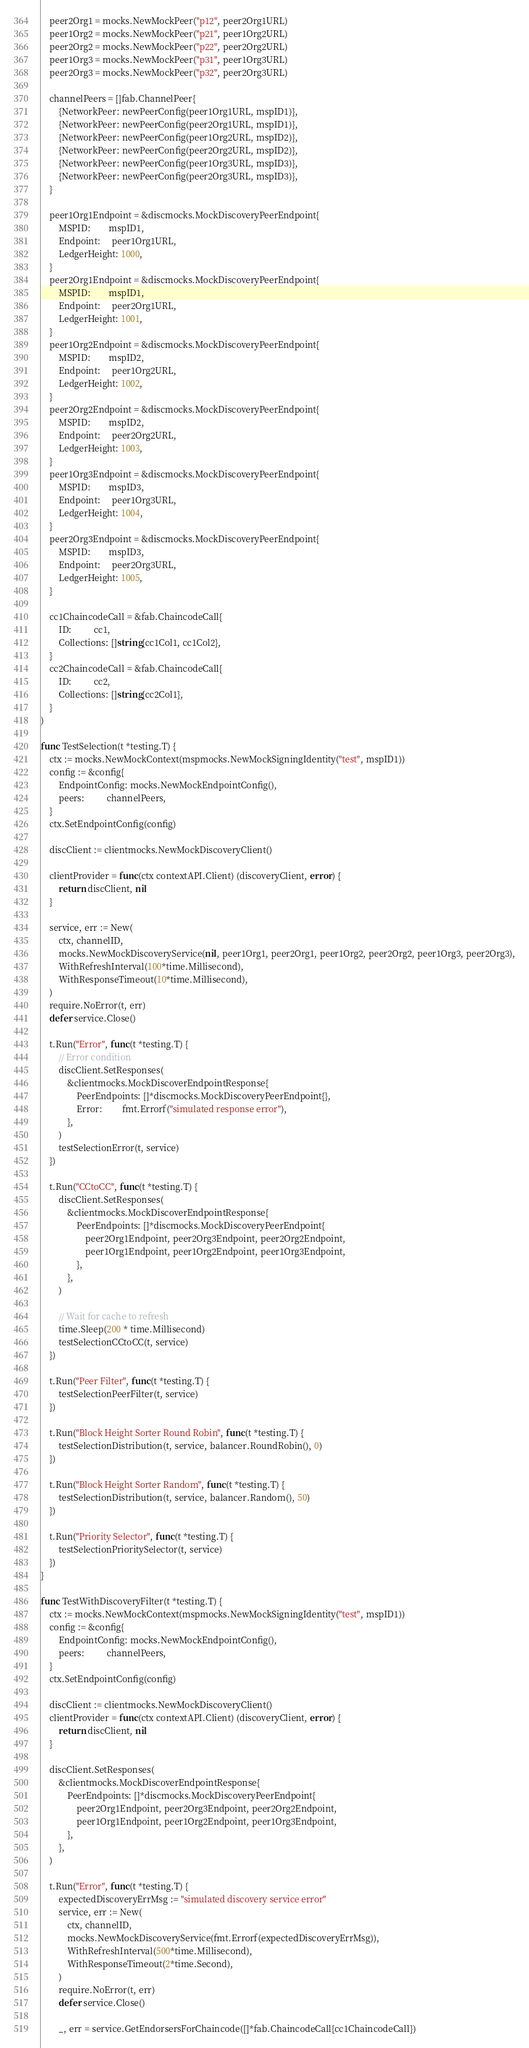<code> <loc_0><loc_0><loc_500><loc_500><_Go_>	peer2Org1 = mocks.NewMockPeer("p12", peer2Org1URL)
	peer1Org2 = mocks.NewMockPeer("p21", peer1Org2URL)
	peer2Org2 = mocks.NewMockPeer("p22", peer2Org2URL)
	peer1Org3 = mocks.NewMockPeer("p31", peer1Org3URL)
	peer2Org3 = mocks.NewMockPeer("p32", peer2Org3URL)

	channelPeers = []fab.ChannelPeer{
		{NetworkPeer: newPeerConfig(peer1Org1URL, mspID1)},
		{NetworkPeer: newPeerConfig(peer2Org1URL, mspID1)},
		{NetworkPeer: newPeerConfig(peer1Org2URL, mspID2)},
		{NetworkPeer: newPeerConfig(peer2Org2URL, mspID2)},
		{NetworkPeer: newPeerConfig(peer1Org3URL, mspID3)},
		{NetworkPeer: newPeerConfig(peer2Org3URL, mspID3)},
	}

	peer1Org1Endpoint = &discmocks.MockDiscoveryPeerEndpoint{
		MSPID:        mspID1,
		Endpoint:     peer1Org1URL,
		LedgerHeight: 1000,
	}
	peer2Org1Endpoint = &discmocks.MockDiscoveryPeerEndpoint{
		MSPID:        mspID1,
		Endpoint:     peer2Org1URL,
		LedgerHeight: 1001,
	}
	peer1Org2Endpoint = &discmocks.MockDiscoveryPeerEndpoint{
		MSPID:        mspID2,
		Endpoint:     peer1Org2URL,
		LedgerHeight: 1002,
	}
	peer2Org2Endpoint = &discmocks.MockDiscoveryPeerEndpoint{
		MSPID:        mspID2,
		Endpoint:     peer2Org2URL,
		LedgerHeight: 1003,
	}
	peer1Org3Endpoint = &discmocks.MockDiscoveryPeerEndpoint{
		MSPID:        mspID3,
		Endpoint:     peer1Org3URL,
		LedgerHeight: 1004,
	}
	peer2Org3Endpoint = &discmocks.MockDiscoveryPeerEndpoint{
		MSPID:        mspID3,
		Endpoint:     peer2Org3URL,
		LedgerHeight: 1005,
	}

	cc1ChaincodeCall = &fab.ChaincodeCall{
		ID:          cc1,
		Collections: []string{cc1Col1, cc1Col2},
	}
	cc2ChaincodeCall = &fab.ChaincodeCall{
		ID:          cc2,
		Collections: []string{cc2Col1},
	}
)

func TestSelection(t *testing.T) {
	ctx := mocks.NewMockContext(mspmocks.NewMockSigningIdentity("test", mspID1))
	config := &config{
		EndpointConfig: mocks.NewMockEndpointConfig(),
		peers:          channelPeers,
	}
	ctx.SetEndpointConfig(config)

	discClient := clientmocks.NewMockDiscoveryClient()

	clientProvider = func(ctx contextAPI.Client) (discoveryClient, error) {
		return discClient, nil
	}

	service, err := New(
		ctx, channelID,
		mocks.NewMockDiscoveryService(nil, peer1Org1, peer2Org1, peer1Org2, peer2Org2, peer1Org3, peer2Org3),
		WithRefreshInterval(100*time.Millisecond),
		WithResponseTimeout(10*time.Millisecond),
	)
	require.NoError(t, err)
	defer service.Close()

	t.Run("Error", func(t *testing.T) {
		// Error condition
		discClient.SetResponses(
			&clientmocks.MockDiscoverEndpointResponse{
				PeerEndpoints: []*discmocks.MockDiscoveryPeerEndpoint{},
				Error:         fmt.Errorf("simulated response error"),
			},
		)
		testSelectionError(t, service)
	})

	t.Run("CCtoCC", func(t *testing.T) {
		discClient.SetResponses(
			&clientmocks.MockDiscoverEndpointResponse{
				PeerEndpoints: []*discmocks.MockDiscoveryPeerEndpoint{
					peer2Org1Endpoint, peer2Org3Endpoint, peer2Org2Endpoint,
					peer1Org1Endpoint, peer1Org2Endpoint, peer1Org3Endpoint,
				},
			},
		)

		// Wait for cache to refresh
		time.Sleep(200 * time.Millisecond)
		testSelectionCCtoCC(t, service)
	})

	t.Run("Peer Filter", func(t *testing.T) {
		testSelectionPeerFilter(t, service)
	})

	t.Run("Block Height Sorter Round Robin", func(t *testing.T) {
		testSelectionDistribution(t, service, balancer.RoundRobin(), 0)
	})

	t.Run("Block Height Sorter Random", func(t *testing.T) {
		testSelectionDistribution(t, service, balancer.Random(), 50)
	})

	t.Run("Priority Selector", func(t *testing.T) {
		testSelectionPrioritySelector(t, service)
	})
}

func TestWithDiscoveryFilter(t *testing.T) {
	ctx := mocks.NewMockContext(mspmocks.NewMockSigningIdentity("test", mspID1))
	config := &config{
		EndpointConfig: mocks.NewMockEndpointConfig(),
		peers:          channelPeers,
	}
	ctx.SetEndpointConfig(config)

	discClient := clientmocks.NewMockDiscoveryClient()
	clientProvider = func(ctx contextAPI.Client) (discoveryClient, error) {
		return discClient, nil
	}

	discClient.SetResponses(
		&clientmocks.MockDiscoverEndpointResponse{
			PeerEndpoints: []*discmocks.MockDiscoveryPeerEndpoint{
				peer2Org1Endpoint, peer2Org3Endpoint, peer2Org2Endpoint,
				peer1Org1Endpoint, peer1Org2Endpoint, peer1Org3Endpoint,
			},
		},
	)

	t.Run("Error", func(t *testing.T) {
		expectedDiscoveryErrMsg := "simulated discovery service error"
		service, err := New(
			ctx, channelID,
			mocks.NewMockDiscoveryService(fmt.Errorf(expectedDiscoveryErrMsg)),
			WithRefreshInterval(500*time.Millisecond),
			WithResponseTimeout(2*time.Second),
		)
		require.NoError(t, err)
		defer service.Close()

		_, err = service.GetEndorsersForChaincode([]*fab.ChaincodeCall{cc1ChaincodeCall})</code> 